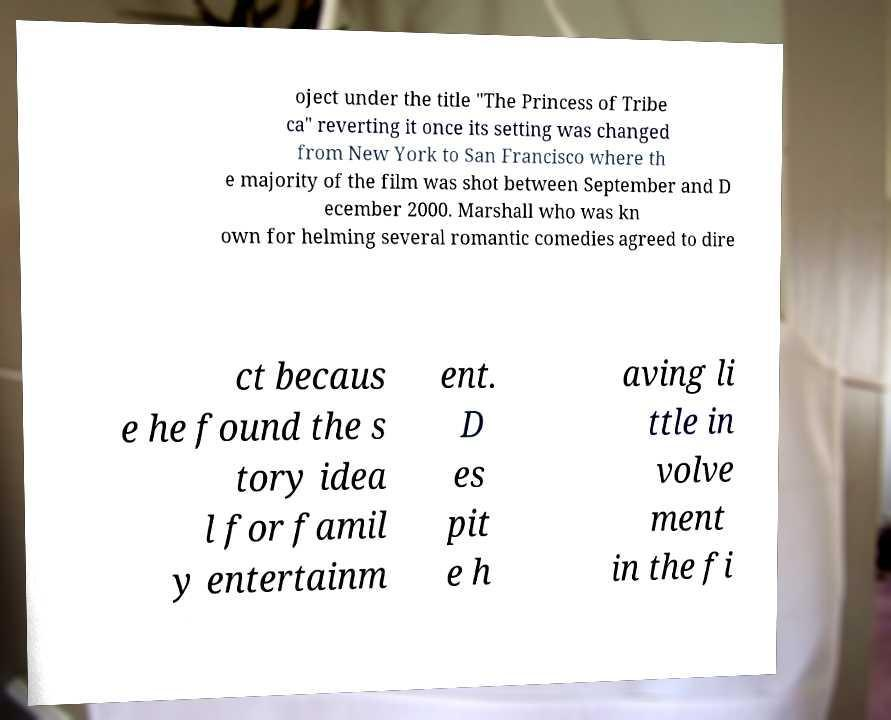Can you accurately transcribe the text from the provided image for me? oject under the title "The Princess of Tribe ca" reverting it once its setting was changed from New York to San Francisco where th e majority of the film was shot between September and D ecember 2000. Marshall who was kn own for helming several romantic comedies agreed to dire ct becaus e he found the s tory idea l for famil y entertainm ent. D es pit e h aving li ttle in volve ment in the fi 